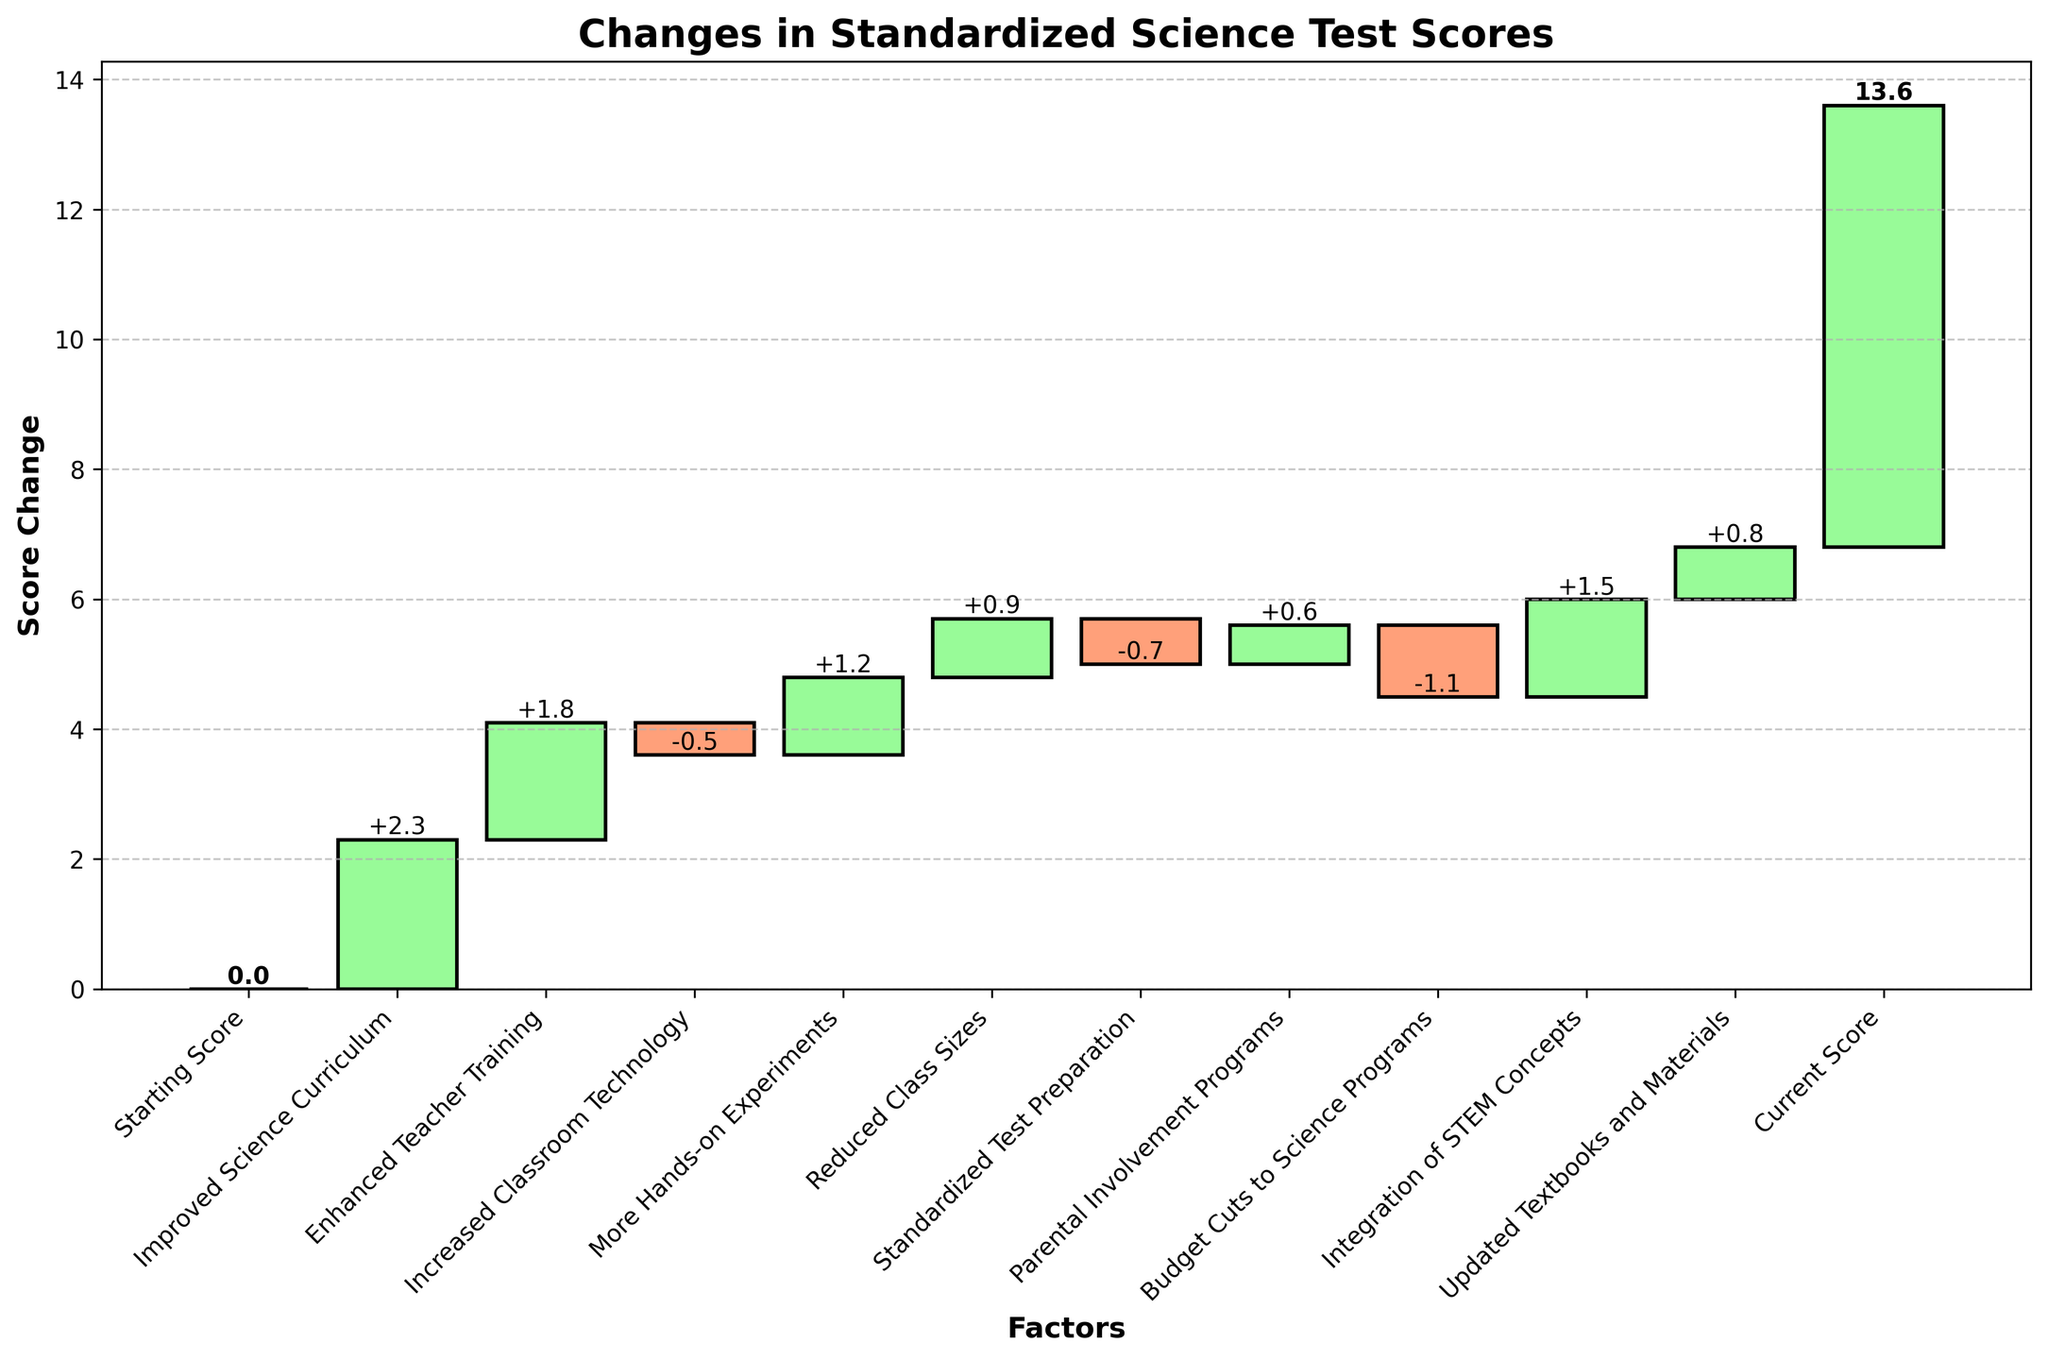How much did the improved science curriculum contribute to the change in test scores? The "Improved Science Curriculum" category shows a change of +2.3, which is indicated by the green bar extending upwards from the previous score.
Answer: +2.3 What is the title of the chart? The title is displayed at the top of the chart in bold text: "Changes in Standardized Science Test Scores".
Answer: Changes in Standardized Science Test Scores How much of an impact did enhanced teacher training have on the test scores? The "Enhanced Teacher Training" category shows a change of +1.8, indicated by the green bar for this category.
Answer: +1.8 Which factor had the most negative impact on the test scores? "Budget Cuts to Science Programs" had the most negative impact, with a change of -1.1, as indicated by the red bar extending downwards.
Answer: Budget Cuts to Science Programs How did increased classroom technology affect the test scores? The "Increased Classroom Technology" category shows a change of -0.5, represented by a red bar extending downwards.
Answer: -0.5 What factors contributed positively to the test scores but by less than 1 point each? The factors contributing positively but less than 1 point are "Reduced Class Sizes" (+0.9), "Parental Involvement Programs" (+0.6), and "Updated Textbooks and Materials" (+0.8).
Answer: Reduced Class Sizes, Parental Involvement Programs, Updated Textbooks and Materials What is the final score after accounting for all the changes? The final score is shown at the end of the waterfall chart. It is labeled "Current Score" with a cumulative score of 6.8.
Answer: 6.8 How many factors resulted in a negative change in the test scores? The negative changes are shown by red bars, and they are "Increased Classroom Technology" (-0.5), "Standardized Test Preparation" (-0.7), and "Budget Cuts to Science Programs" (-1.1). There are 3 such factors.
Answer: 3 Which factor had the smallest positive contribution to the test scores? "Parental Involvement Programs" contributed the smallest positive change of +0.6, as indicated by its green bar.
Answer: Parental Involvement Programs What is the cumulative score change from hands-on experiments and integration of STEM concepts? The change from "More Hands-on Experiments" is +1.2, and from "Integration of STEM Concepts" is +1.5. Their combined effect is +1.2 + +1.5 = +2.7.
Answer: +2.7 